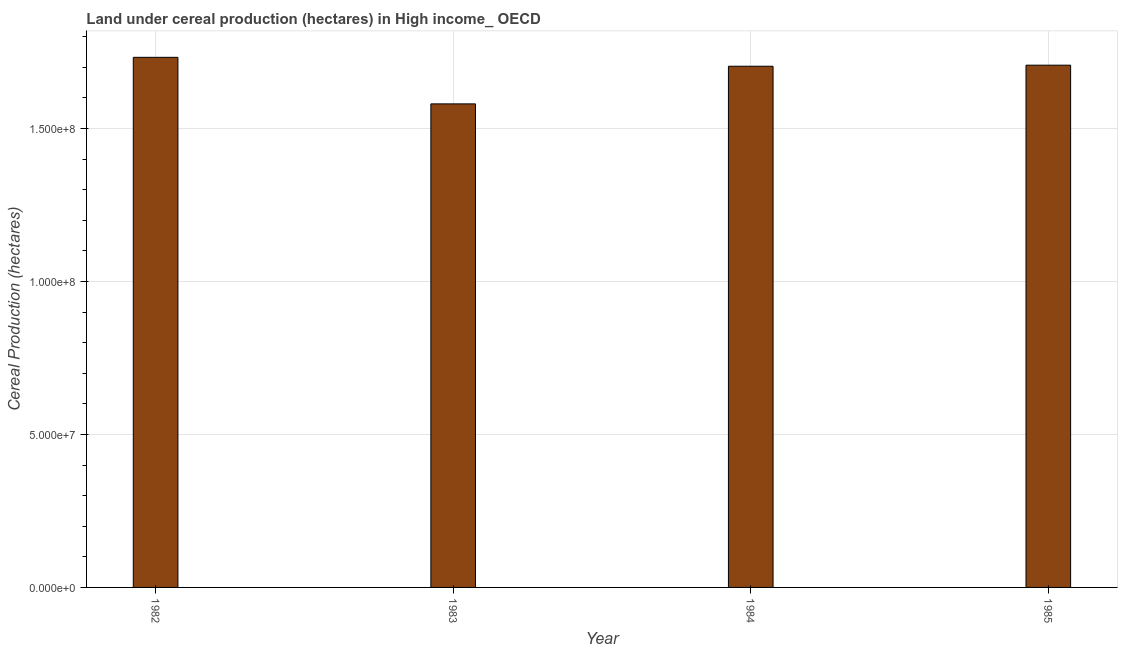Does the graph contain any zero values?
Give a very brief answer. No. Does the graph contain grids?
Offer a terse response. Yes. What is the title of the graph?
Your response must be concise. Land under cereal production (hectares) in High income_ OECD. What is the label or title of the X-axis?
Offer a very short reply. Year. What is the label or title of the Y-axis?
Provide a short and direct response. Cereal Production (hectares). What is the land under cereal production in 1983?
Keep it short and to the point. 1.58e+08. Across all years, what is the maximum land under cereal production?
Your answer should be very brief. 1.73e+08. Across all years, what is the minimum land under cereal production?
Your answer should be compact. 1.58e+08. In which year was the land under cereal production maximum?
Keep it short and to the point. 1982. What is the sum of the land under cereal production?
Your answer should be very brief. 6.72e+08. What is the difference between the land under cereal production in 1982 and 1985?
Keep it short and to the point. 2.57e+06. What is the average land under cereal production per year?
Offer a very short reply. 1.68e+08. What is the median land under cereal production?
Give a very brief answer. 1.71e+08. Do a majority of the years between 1984 and 1985 (inclusive) have land under cereal production greater than 90000000 hectares?
Make the answer very short. Yes. What is the ratio of the land under cereal production in 1984 to that in 1985?
Your answer should be very brief. 1. Is the land under cereal production in 1984 less than that in 1985?
Give a very brief answer. Yes. Is the difference between the land under cereal production in 1984 and 1985 greater than the difference between any two years?
Offer a very short reply. No. What is the difference between the highest and the second highest land under cereal production?
Your answer should be very brief. 2.57e+06. What is the difference between the highest and the lowest land under cereal production?
Make the answer very short. 1.52e+07. In how many years, is the land under cereal production greater than the average land under cereal production taken over all years?
Make the answer very short. 3. How many bars are there?
Offer a terse response. 4. What is the difference between two consecutive major ticks on the Y-axis?
Your answer should be compact. 5.00e+07. What is the Cereal Production (hectares) of 1982?
Ensure brevity in your answer.  1.73e+08. What is the Cereal Production (hectares) in 1983?
Offer a very short reply. 1.58e+08. What is the Cereal Production (hectares) in 1984?
Offer a terse response. 1.70e+08. What is the Cereal Production (hectares) in 1985?
Your response must be concise. 1.71e+08. What is the difference between the Cereal Production (hectares) in 1982 and 1983?
Ensure brevity in your answer.  1.52e+07. What is the difference between the Cereal Production (hectares) in 1982 and 1984?
Make the answer very short. 2.91e+06. What is the difference between the Cereal Production (hectares) in 1982 and 1985?
Offer a terse response. 2.57e+06. What is the difference between the Cereal Production (hectares) in 1983 and 1984?
Make the answer very short. -1.23e+07. What is the difference between the Cereal Production (hectares) in 1983 and 1985?
Your answer should be very brief. -1.26e+07. What is the difference between the Cereal Production (hectares) in 1984 and 1985?
Provide a short and direct response. -3.46e+05. What is the ratio of the Cereal Production (hectares) in 1982 to that in 1983?
Give a very brief answer. 1.1. What is the ratio of the Cereal Production (hectares) in 1982 to that in 1984?
Offer a very short reply. 1.02. What is the ratio of the Cereal Production (hectares) in 1983 to that in 1984?
Give a very brief answer. 0.93. What is the ratio of the Cereal Production (hectares) in 1983 to that in 1985?
Your response must be concise. 0.93. What is the ratio of the Cereal Production (hectares) in 1984 to that in 1985?
Your response must be concise. 1. 